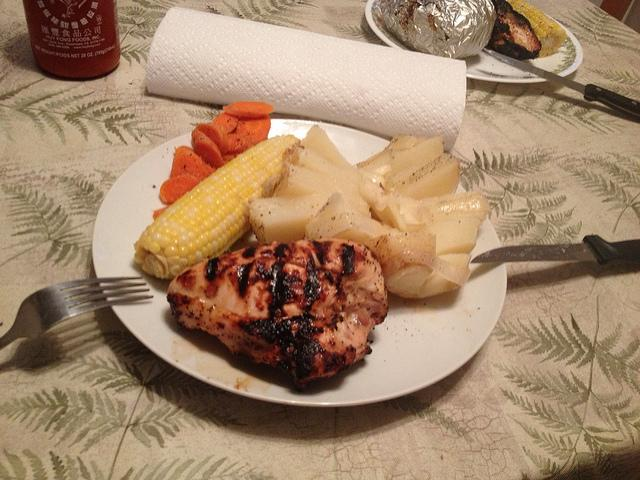What was used to cook the meat and potatoes of the dish? Please explain your reasoning. grill. The chicken has grill marks. 